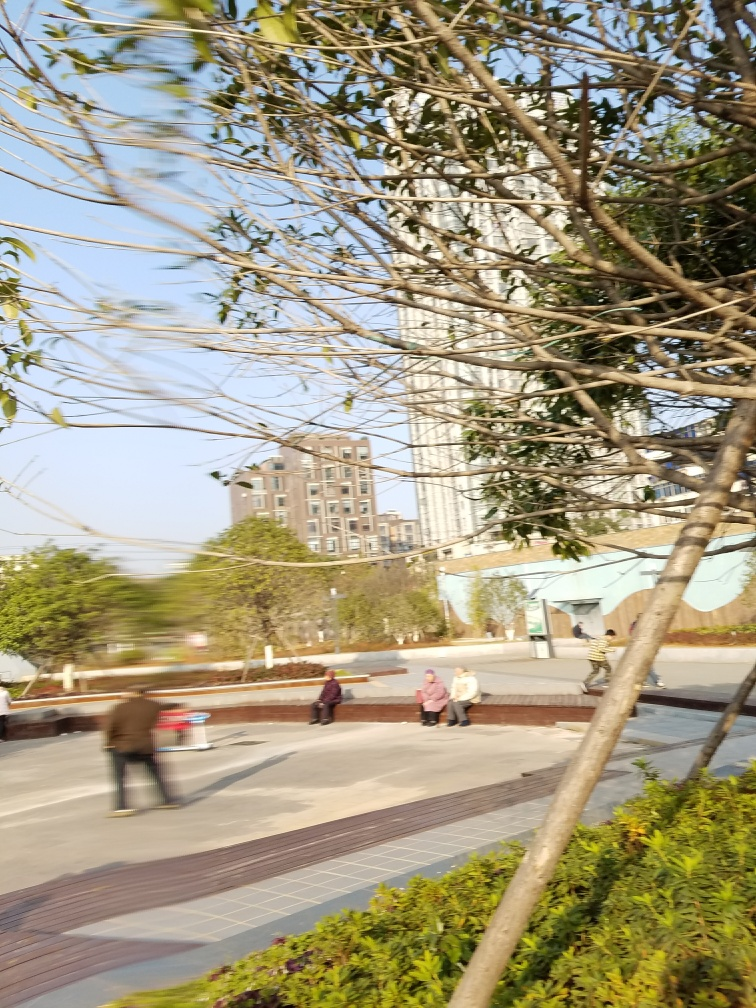How would you describe the colors in the photo? The colors in the photo are warm and natural, featuring a variety of earthy tones punctuated by the greens of foliage and the neutral hues of the pavement and buildings. The sunlight casts a soft glow, adding a golden quality to the scene, which suggests the photo was taken during the early evening or late afternoon. 